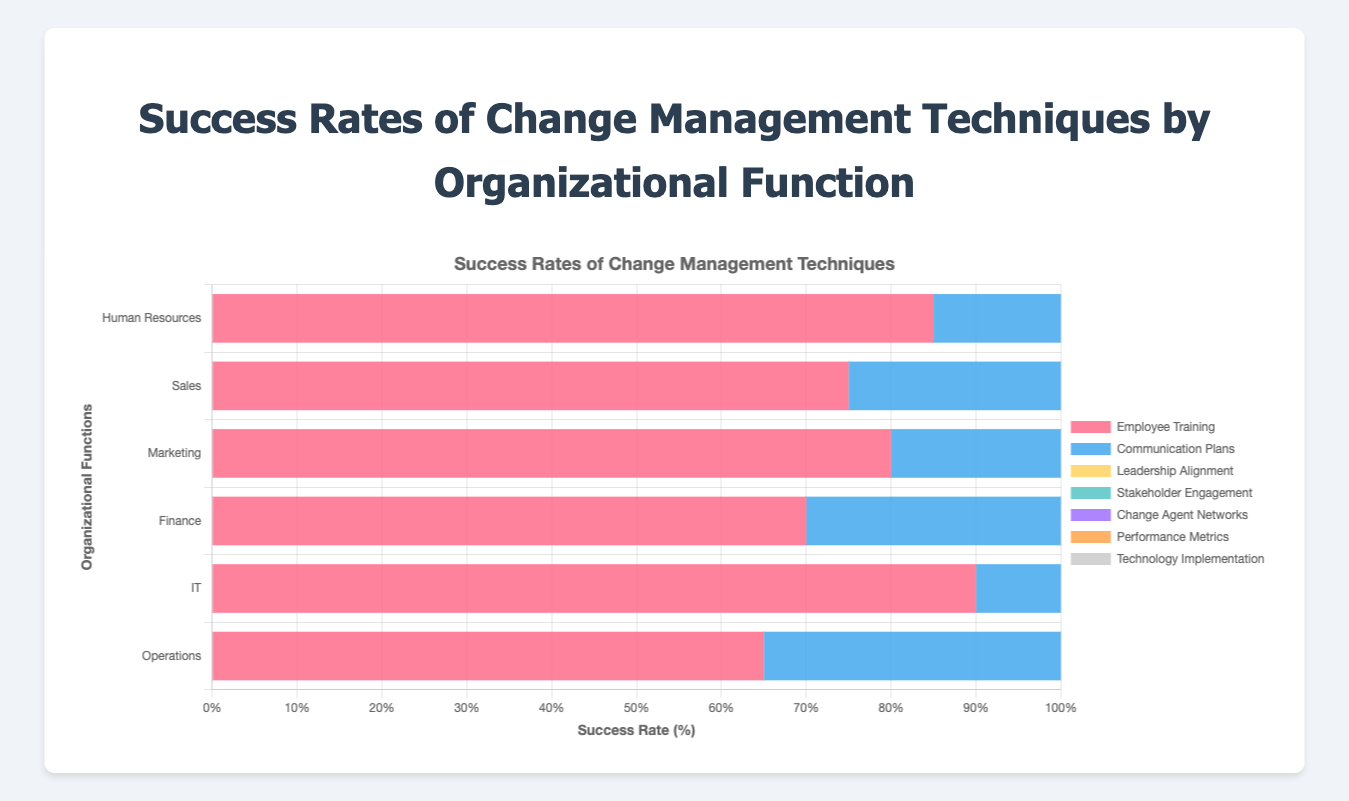Which organizational function has the highest success rate for employee training? Look for the highest value in the 'Employee Training' series. The highest value is 90 for IT.
Answer: IT Which change management technique has the lowest success rate in Operations? Refer to the Operations row and find the smallest value across all techniques. The lowest value is 65 for Employee Training.
Answer: Employee Training Is the success rate of communication plans in Human Resources greater than stakeholder engagement in Finance? Compare the values for Human Resources in 'Communication Plans' and Finance in 'Stakeholder Engagement'. Human Resources for 'Communication Plans' is 90 and Finance for 'Stakeholder Engagement' is 80.
Answer: Yes What's the average success rate of technology implementation across all organizational functions? Sum the success rates of technology implementation for each function: 72 (HR) + 65 (Sales) + 67 (Marketing) + 71 (Finance) + 85 (IT) + 70 (Operations) = 430. Divide by the number of functions, which is 6. The average is 430 / 6 = 71.67.
Answer: 71.67 Which two organizational functions have the closest success rates for change agent networks? Compare the success rates for 'Change Agent Networks' for all functions and find the two closest values. HR (79), Sales (70), Marketing (69), Finance (74), IT (75), Operations (68). The closest rates are Sales (70) and Marketing (69).
Answer: Sales and Marketing Is the success rate of leadership alignment in IT higher or lower than the success rate of performance metrics in Sales? Compare the values for IT in 'Leadership Alignment' and Sales in 'Performance Metrics'. IT for 'Leadership Alignment' is 83 and Sales for 'Performance Metrics' is 78.
Answer: Higher Which organizational function shows the highest success rate for stakeholder engagement? Refer to the 'Stakeholder Engagement' column and identify the highest value. The highest value is 88 for Human Resources.
Answer: Human Resources What is the difference in success rates between communication plans and employee training in Marketing? Subtract the success rate of 'Employee Training' from 'Communication Plans' in Marketing. 'Communication Plans' is 78 and 'Employee Training' is 80. The difference is 78 - 80 = -2.
Answer: -2 What is the sum of success rates of performance metrics for Human Resources and Finance? Add the success rates of 'Performance Metrics' for Human Resources and Finance. HR (81) + Finance (76) = 157.
Answer: 157 What's the median success rate for stakeholder engagement across all organizational functions? Arrange the success rates for 'Stakeholder Engagement' from least to greatest: 78 (Operations), 80 (Finance), 82 (Marketing), 83 (Sales), 84 (IT), 88 (HR). The median is (82+83)/2 = 82.5.
Answer: 82.5 